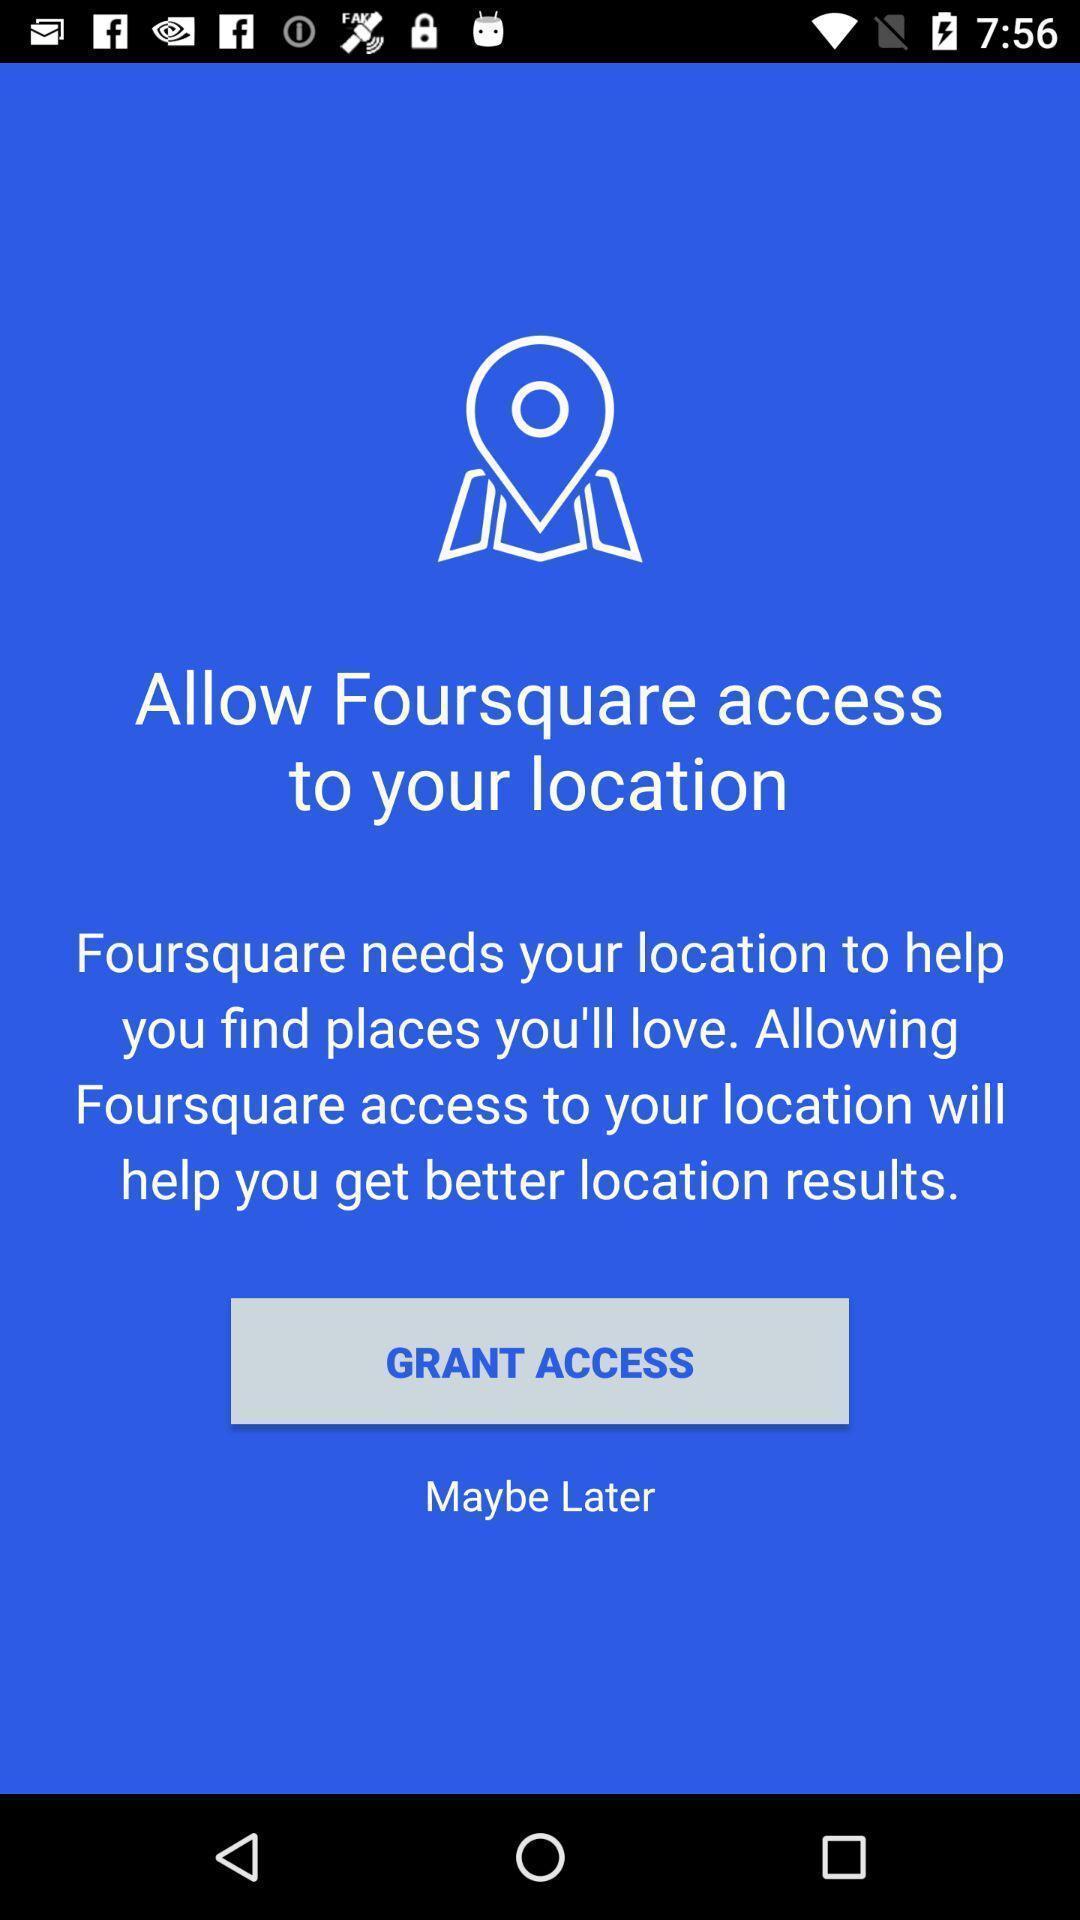What details can you identify in this image? Page displaying allow access to location. 